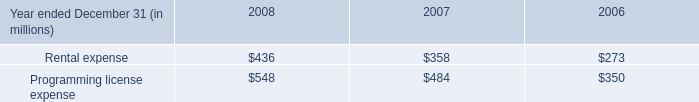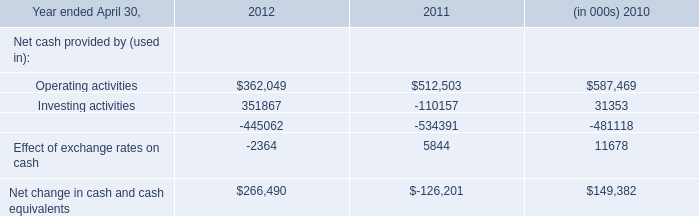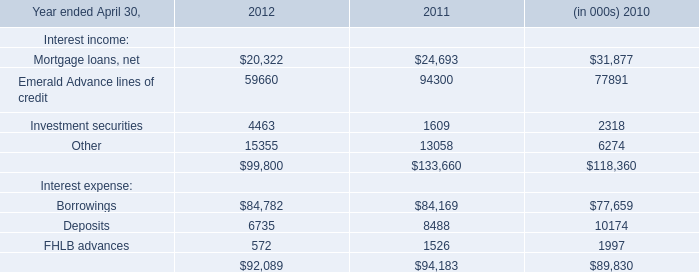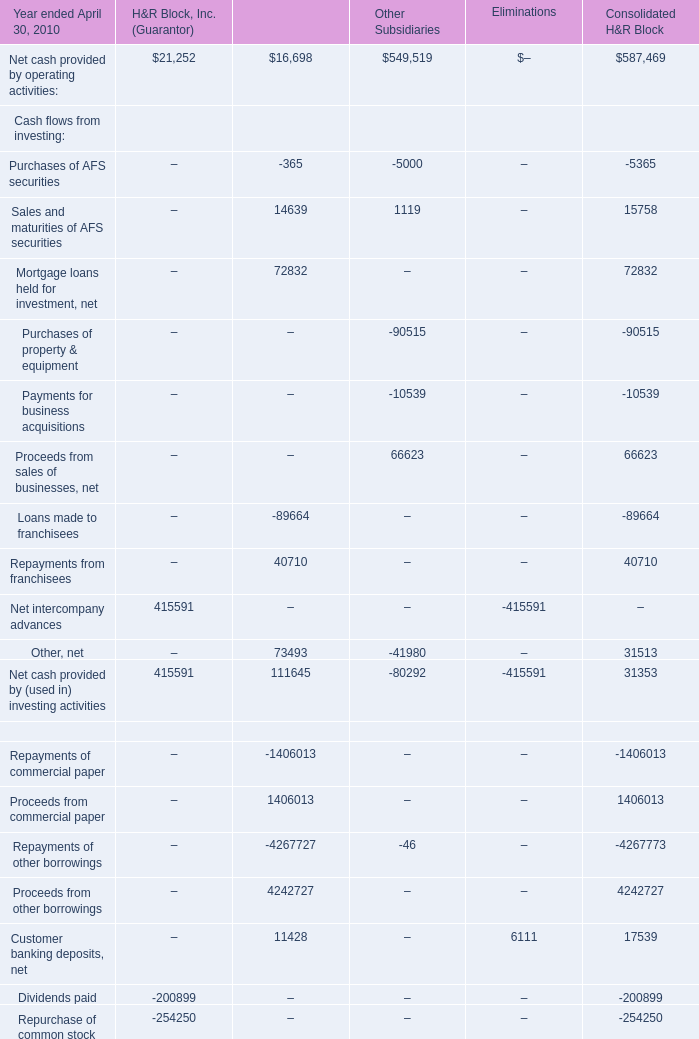What's the sum of all Net cash provided by operating activities: that are positive in2010 ? 
Computations: (((21252 + 16698) + 549519) + 587469)
Answer: 1174938.0. 